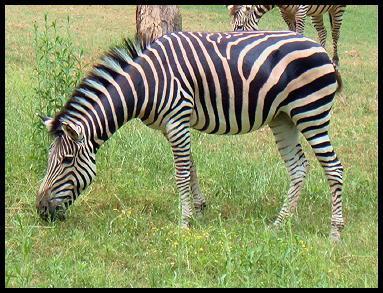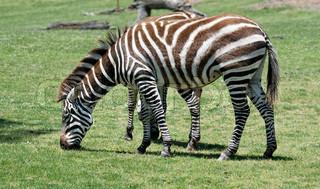The first image is the image on the left, the second image is the image on the right. Evaluate the accuracy of this statement regarding the images: "The right image contains one zebra with lowered head and body in profile, and the left image features two zebras side-to-side with bodies parallel.". Is it true? Answer yes or no. No. 